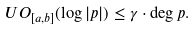Convert formula to latex. <formula><loc_0><loc_0><loc_500><loc_500>U O _ { [ a , b ] } ( \log | p | ) \leq \gamma \cdot \deg p .</formula> 